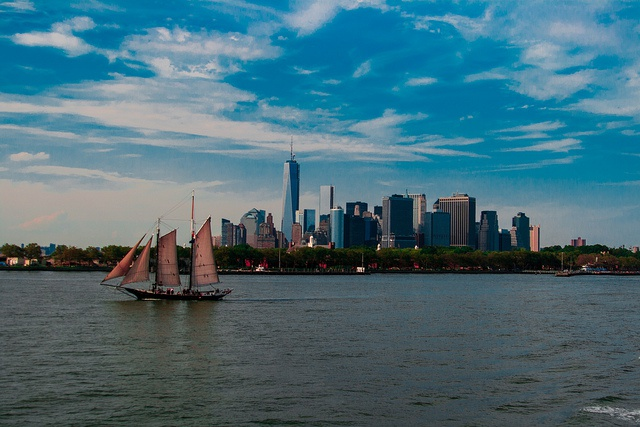Describe the objects in this image and their specific colors. I can see boat in teal, black, gray, brown, and maroon tones, people in black, gray, and teal tones, and people in teal, black, maroon, gray, and lightpink tones in this image. 